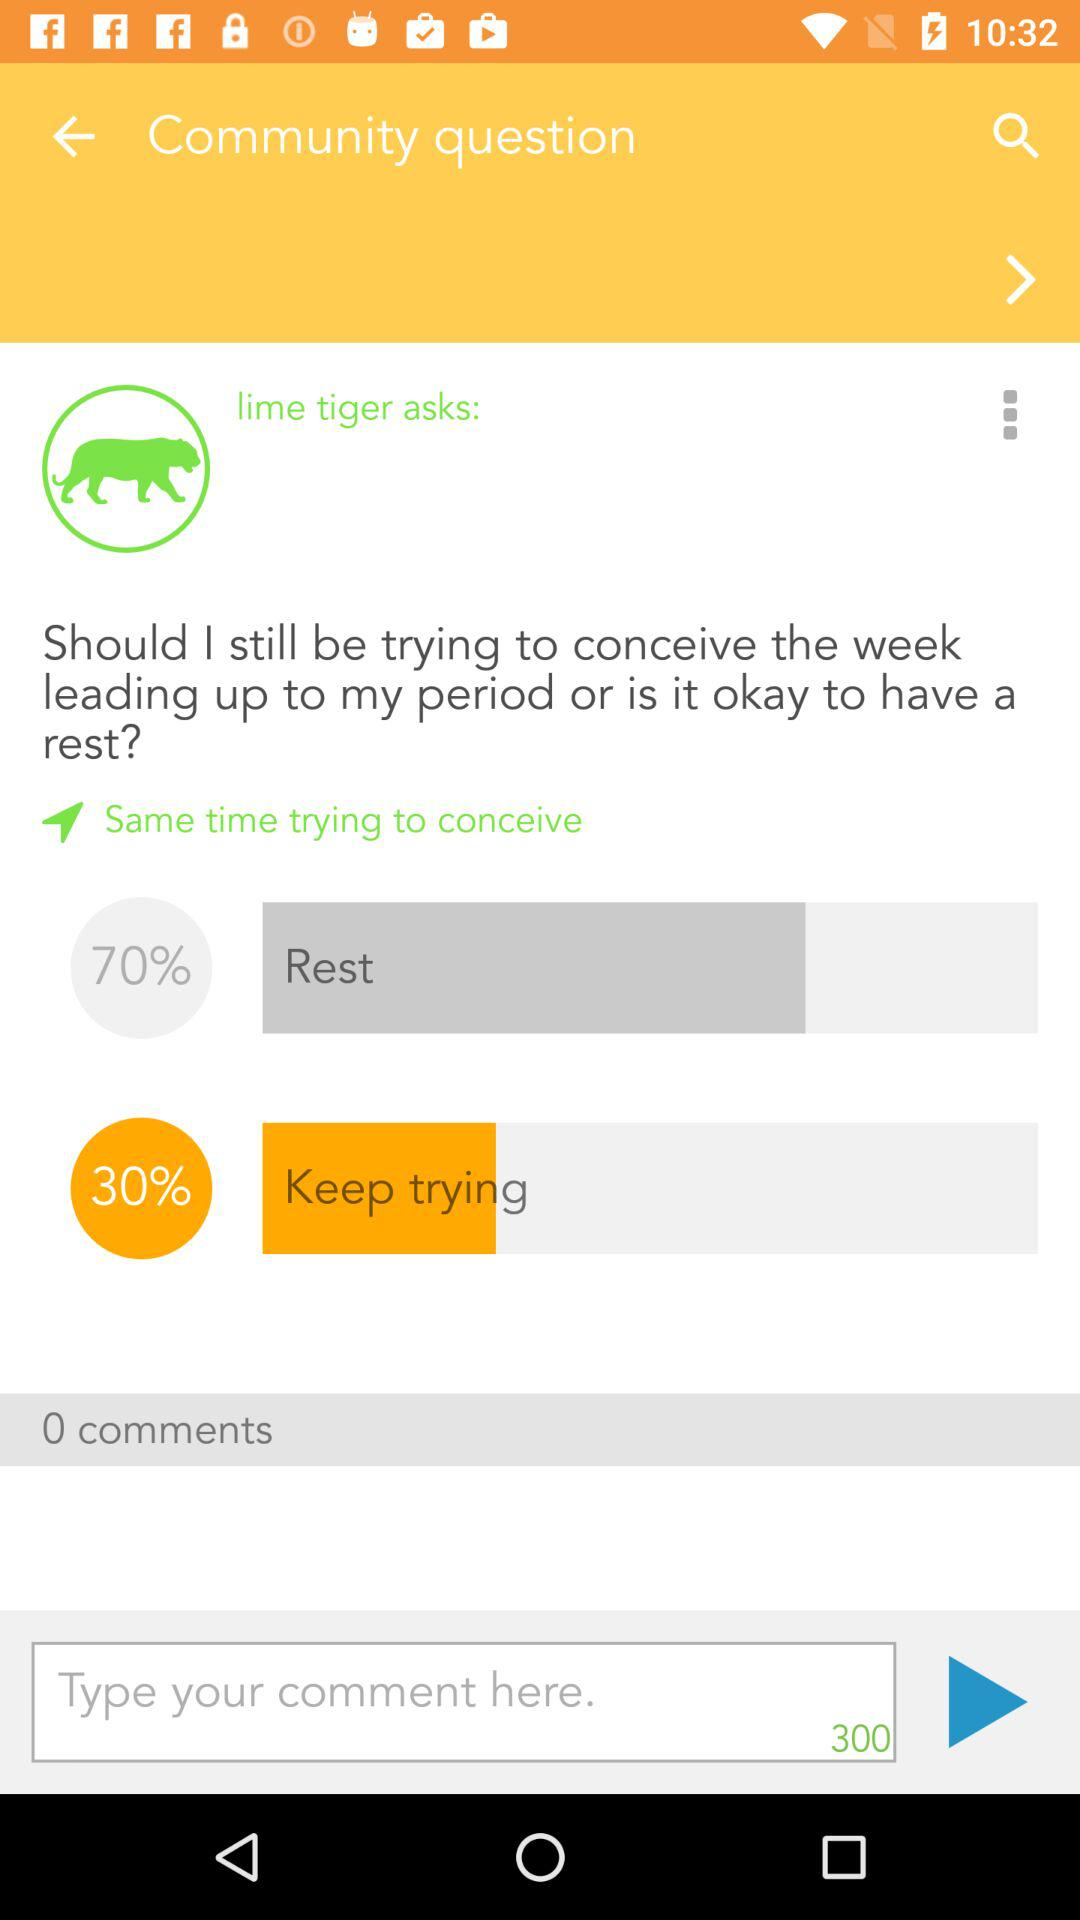How many comments are there? There are 0 comments. 